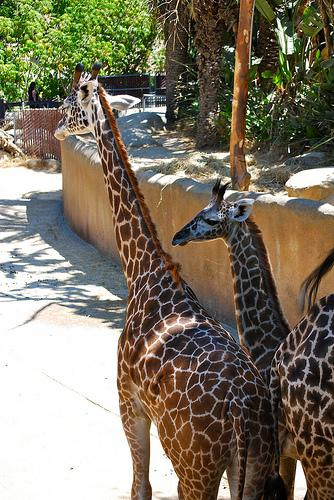Mention one notable feature that can be observed on the giraffes' heads. The giraffes have ossicones, which are horn-like structures, on their heads. Describe the surroundings of the giraffes in the image. The giraffes are standing near a concrete wall, surrounded by trees, in what seems to be a zoo with a fence. Identify how many giraffes are in the image and describe their appearance. There are three giraffes with tan skin and brown spots, standing next to each other beside a wall. Are there any human beings or man-made structures in the image? If so, what are they doing or what purpose do they serve? Yes, there is a person standing near the trees and a telephone pole made out of wood. What details are visible regarding the tail of the giraffe on the right? The tail of the giraffe on the right is visible with a dimension of 14 pixels in width and height. Describe one of the giraffes' body features in terms of its positioning and relative size. The front left leg of the giraffe on the left has a width of 32 pixels and a height of 400 pixels. What can you deduce about the environment where the giraffes are located? The giraffes are in a zoo or a protected park-like environment with trees, shadows, walls, and fences. In a few words, provide an overall description of the image's content. The image displays three spotted giraffes beside a concrete wall, surrounded by trees and a fence in a zoo-like environment. What type of wall is shown and mention the additional feature present on it? The wall is made of concrete and has large rocks and a stone placed above it. Count the total number of trees and briefly describe their appearance. There are tall leafy green trees with brown trunks, probably palm trees, totaling to six. Evaluate the quality of the image captured. High quality with clear and detailed objects. List the various objects surrounding the giraffe. Trees, wall, telephone pole, fence, rocks, and ground. Identify the objects that are interacting with the giraffes. The ground, shadow of the trees, and the wall. Give the emotion or sentiment of the scene in the image. Neutral or calm. Is the palm tree trunk right next to the baby giraffe green? The palm tree trunks mentioned in the image information are described as brown, not green. Are the spots on the giraffes blue instead of brown? The spots on the giraffes are described as brown in the image information, not blue. Do the giraffes have yellow manes instead of red ones? The giraffes are described as having red manes, not yellow manes. How many giraffes are in the image, and what are their characteristics? Three giraffes, all tan with brown spots, red mane, and ossicones on their heads. A baby giraffe is also present. Identify the text written in the image. There is no text present in the image. What type of trees have their shadows cast in the image? Tall leafy green trees and palm trees. Detect the multiple-choice question in the image. There is no multiple-choice question in the image. Is the wall behind the giraffes made of wood instead of concrete? The wall is described as being made of concrete, not wood. What type of pole is in the image, and what is it made out of? It is a telephone pole made out of wood. Find the referential expressions for the baby giraffe. X:198 Y:160 Width:125 Height:125 What is the unique object present above the wall? A stone. What is the color of the giraffe's mane? Red Can you see a white fence instead of a metal chain link fence with brown lattice? The image information describes a metal chain link fence with brown lattice, not a white fence. What are some of the ground features where the giraffes are walking? Shadows cast by palm trees and ground texture. What are the unique features of the giraffe's head? Ossicones, ears, and nose/mouth area. Is there a dog sitting near the trees instead of a person? The image information mentions a person standing near the trees, not a dog. Describe the fence present in the image. A metal chain link fence with brown lattice. What are the baby giraffe's surroundings? Other giraffes, trees, wall, shadow of the trees, and ground. Describe the giraffe on the left side of the image. A tall giraffe with brown spots and a red mane. It has ossicones on its head, and its front leg and back left leg are visible. Which area on the giraffes have brown spots? On their back and sides. What type of wall is beside the giraffe, and what objects are on it? A concrete wall with large rocks and a stone above it. 